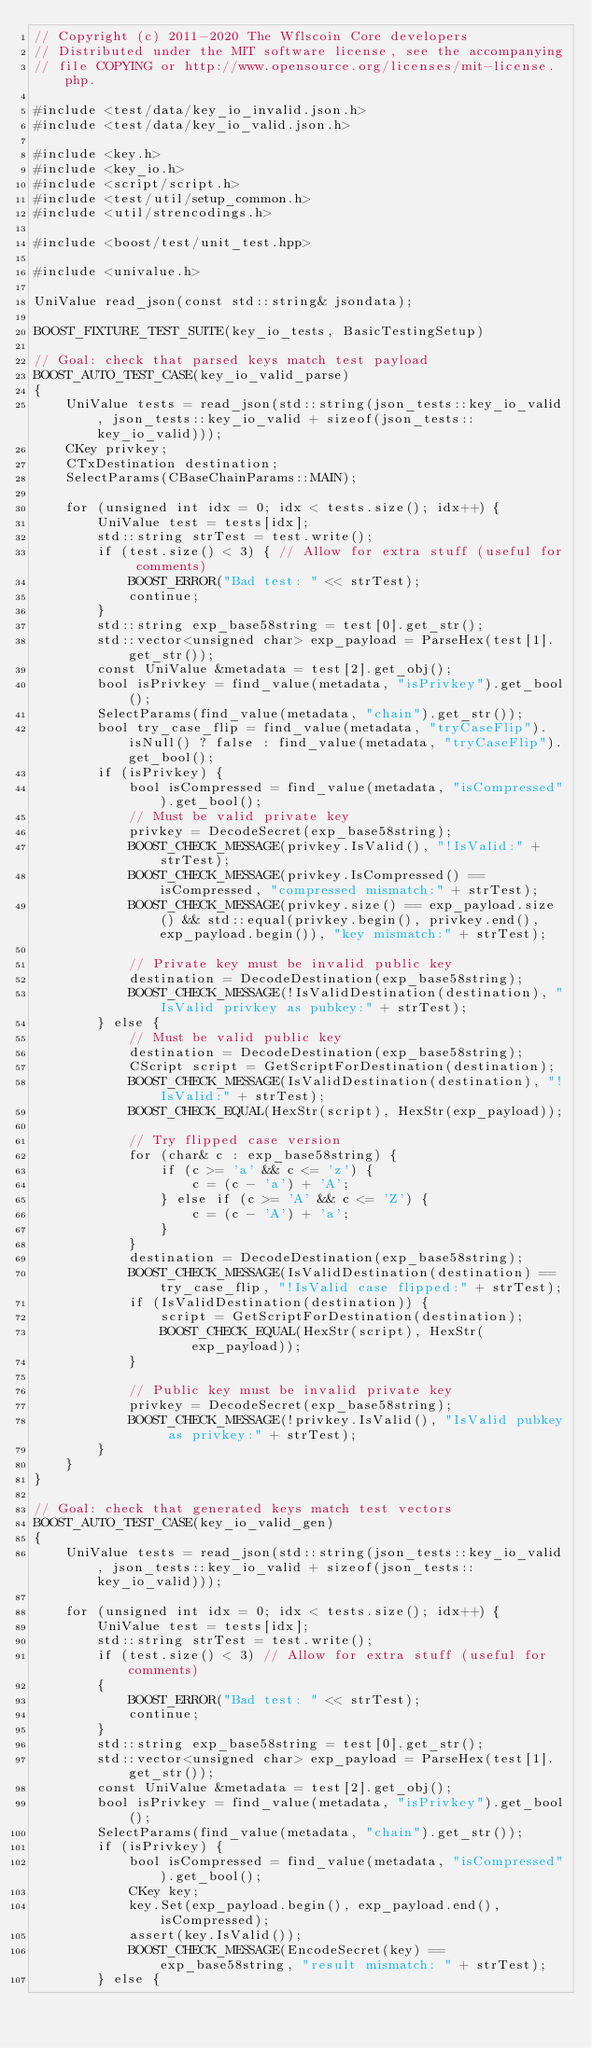<code> <loc_0><loc_0><loc_500><loc_500><_C++_>// Copyright (c) 2011-2020 The Wflscoin Core developers
// Distributed under the MIT software license, see the accompanying
// file COPYING or http://www.opensource.org/licenses/mit-license.php.

#include <test/data/key_io_invalid.json.h>
#include <test/data/key_io_valid.json.h>

#include <key.h>
#include <key_io.h>
#include <script/script.h>
#include <test/util/setup_common.h>
#include <util/strencodings.h>

#include <boost/test/unit_test.hpp>

#include <univalue.h>

UniValue read_json(const std::string& jsondata);

BOOST_FIXTURE_TEST_SUITE(key_io_tests, BasicTestingSetup)

// Goal: check that parsed keys match test payload
BOOST_AUTO_TEST_CASE(key_io_valid_parse)
{
    UniValue tests = read_json(std::string(json_tests::key_io_valid, json_tests::key_io_valid + sizeof(json_tests::key_io_valid)));
    CKey privkey;
    CTxDestination destination;
    SelectParams(CBaseChainParams::MAIN);

    for (unsigned int idx = 0; idx < tests.size(); idx++) {
        UniValue test = tests[idx];
        std::string strTest = test.write();
        if (test.size() < 3) { // Allow for extra stuff (useful for comments)
            BOOST_ERROR("Bad test: " << strTest);
            continue;
        }
        std::string exp_base58string = test[0].get_str();
        std::vector<unsigned char> exp_payload = ParseHex(test[1].get_str());
        const UniValue &metadata = test[2].get_obj();
        bool isPrivkey = find_value(metadata, "isPrivkey").get_bool();
        SelectParams(find_value(metadata, "chain").get_str());
        bool try_case_flip = find_value(metadata, "tryCaseFlip").isNull() ? false : find_value(metadata, "tryCaseFlip").get_bool();
        if (isPrivkey) {
            bool isCompressed = find_value(metadata, "isCompressed").get_bool();
            // Must be valid private key
            privkey = DecodeSecret(exp_base58string);
            BOOST_CHECK_MESSAGE(privkey.IsValid(), "!IsValid:" + strTest);
            BOOST_CHECK_MESSAGE(privkey.IsCompressed() == isCompressed, "compressed mismatch:" + strTest);
            BOOST_CHECK_MESSAGE(privkey.size() == exp_payload.size() && std::equal(privkey.begin(), privkey.end(), exp_payload.begin()), "key mismatch:" + strTest);

            // Private key must be invalid public key
            destination = DecodeDestination(exp_base58string);
            BOOST_CHECK_MESSAGE(!IsValidDestination(destination), "IsValid privkey as pubkey:" + strTest);
        } else {
            // Must be valid public key
            destination = DecodeDestination(exp_base58string);
            CScript script = GetScriptForDestination(destination);
            BOOST_CHECK_MESSAGE(IsValidDestination(destination), "!IsValid:" + strTest);
            BOOST_CHECK_EQUAL(HexStr(script), HexStr(exp_payload));

            // Try flipped case version
            for (char& c : exp_base58string) {
                if (c >= 'a' && c <= 'z') {
                    c = (c - 'a') + 'A';
                } else if (c >= 'A' && c <= 'Z') {
                    c = (c - 'A') + 'a';
                }
            }
            destination = DecodeDestination(exp_base58string);
            BOOST_CHECK_MESSAGE(IsValidDestination(destination) == try_case_flip, "!IsValid case flipped:" + strTest);
            if (IsValidDestination(destination)) {
                script = GetScriptForDestination(destination);
                BOOST_CHECK_EQUAL(HexStr(script), HexStr(exp_payload));
            }

            // Public key must be invalid private key
            privkey = DecodeSecret(exp_base58string);
            BOOST_CHECK_MESSAGE(!privkey.IsValid(), "IsValid pubkey as privkey:" + strTest);
        }
    }
}

// Goal: check that generated keys match test vectors
BOOST_AUTO_TEST_CASE(key_io_valid_gen)
{
    UniValue tests = read_json(std::string(json_tests::key_io_valid, json_tests::key_io_valid + sizeof(json_tests::key_io_valid)));

    for (unsigned int idx = 0; idx < tests.size(); idx++) {
        UniValue test = tests[idx];
        std::string strTest = test.write();
        if (test.size() < 3) // Allow for extra stuff (useful for comments)
        {
            BOOST_ERROR("Bad test: " << strTest);
            continue;
        }
        std::string exp_base58string = test[0].get_str();
        std::vector<unsigned char> exp_payload = ParseHex(test[1].get_str());
        const UniValue &metadata = test[2].get_obj();
        bool isPrivkey = find_value(metadata, "isPrivkey").get_bool();
        SelectParams(find_value(metadata, "chain").get_str());
        if (isPrivkey) {
            bool isCompressed = find_value(metadata, "isCompressed").get_bool();
            CKey key;
            key.Set(exp_payload.begin(), exp_payload.end(), isCompressed);
            assert(key.IsValid());
            BOOST_CHECK_MESSAGE(EncodeSecret(key) == exp_base58string, "result mismatch: " + strTest);
        } else {</code> 